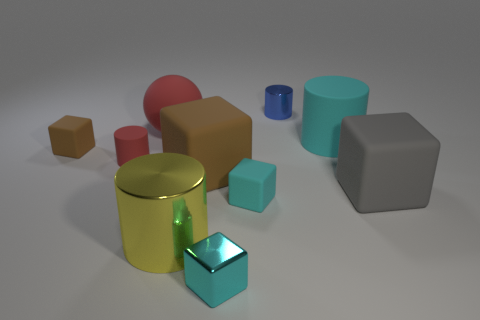Subtract all tiny metal cylinders. How many cylinders are left? 3 Subtract all gray blocks. How many blocks are left? 4 Subtract all blue cubes. Subtract all blue cylinders. How many cubes are left? 5 Subtract all balls. How many objects are left? 9 Add 6 balls. How many balls are left? 7 Add 5 tiny red rubber cubes. How many tiny red rubber cubes exist? 5 Subtract 0 gray balls. How many objects are left? 10 Subtract all small blue metal things. Subtract all gray matte things. How many objects are left? 8 